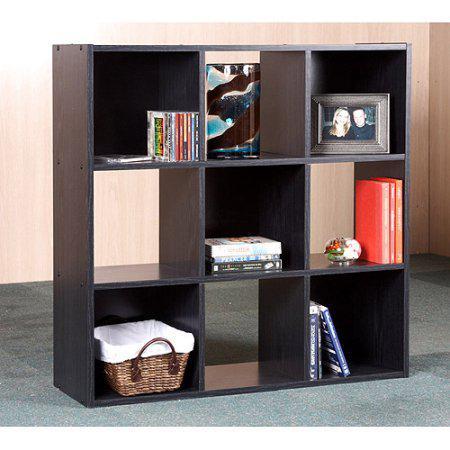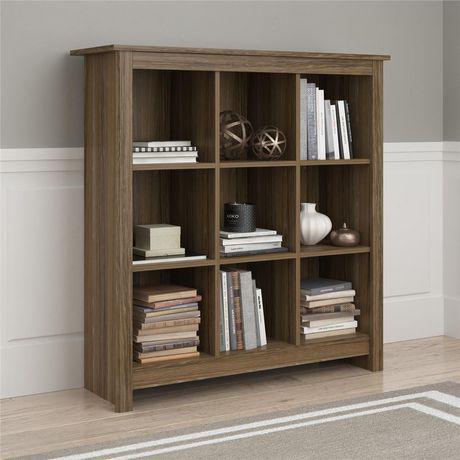The first image is the image on the left, the second image is the image on the right. Analyze the images presented: Is the assertion "There is a window visible in one of the photos." valid? Answer yes or no. No. The first image is the image on the left, the second image is the image on the right. For the images shown, is this caption "An image of a brown bookshelf includes a ladder design of some type." true? Answer yes or no. No. 